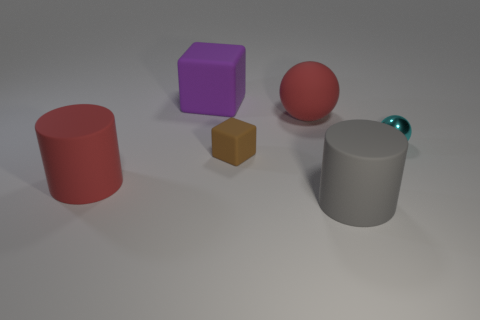There is a tiny cube; are there any red rubber objects right of it?
Your answer should be compact. Yes. There is a red rubber thing that is on the right side of the red thing that is to the left of the small brown block; what shape is it?
Offer a very short reply. Sphere. Is the number of purple matte objects in front of the tiny cube less than the number of brown blocks that are behind the metal thing?
Your answer should be very brief. No. What is the color of the small thing that is the same shape as the big purple object?
Your answer should be very brief. Brown. How many matte objects are both in front of the small brown cube and behind the big gray rubber object?
Make the answer very short. 1. Is the number of large red things in front of the tiny rubber object greater than the number of cyan metallic spheres behind the cyan shiny object?
Ensure brevity in your answer.  Yes. What size is the red matte cylinder?
Your answer should be compact. Large. Is there a large purple object of the same shape as the small matte thing?
Make the answer very short. Yes. There is a big gray thing; does it have the same shape as the red matte object in front of the tiny cube?
Give a very brief answer. Yes. What size is the rubber object that is right of the purple rubber block and to the left of the large red ball?
Your answer should be compact. Small. 